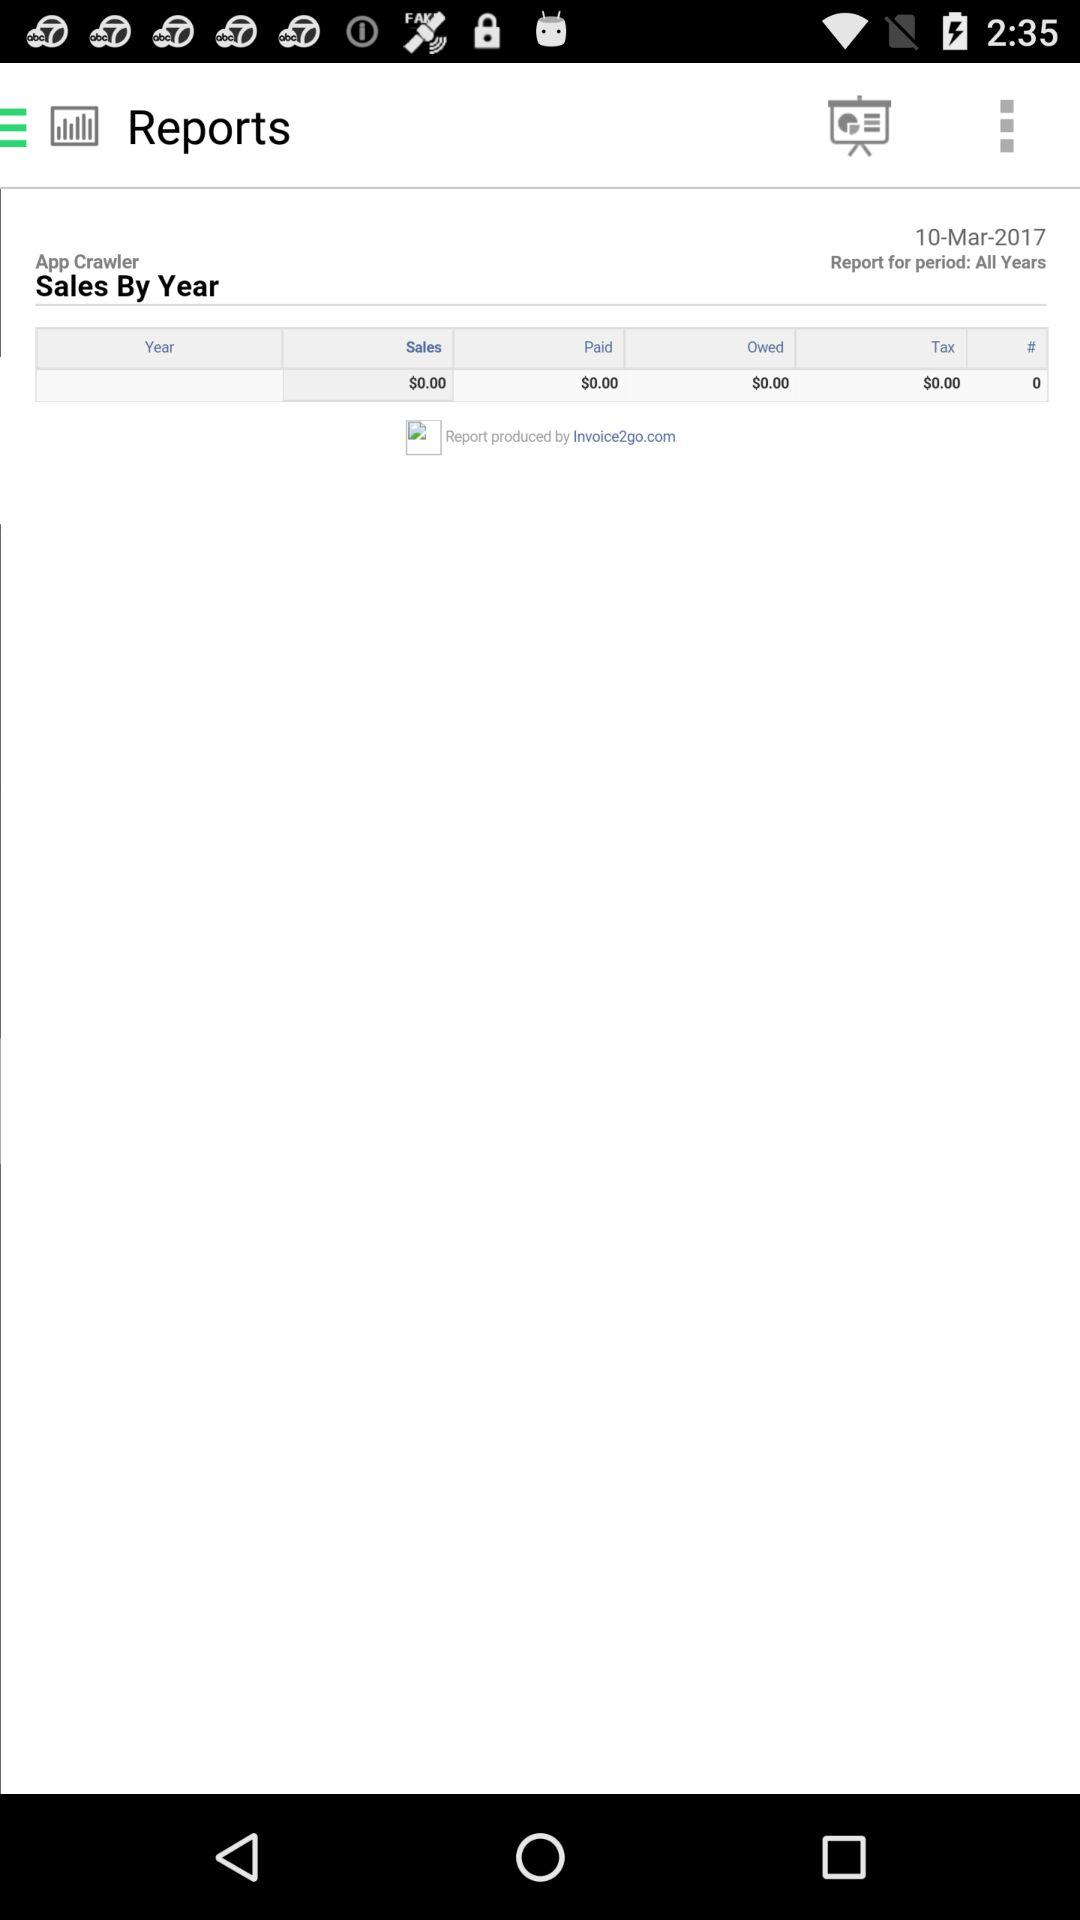What is the total number of sales in dollars? The total amount of sales is $0.00. 